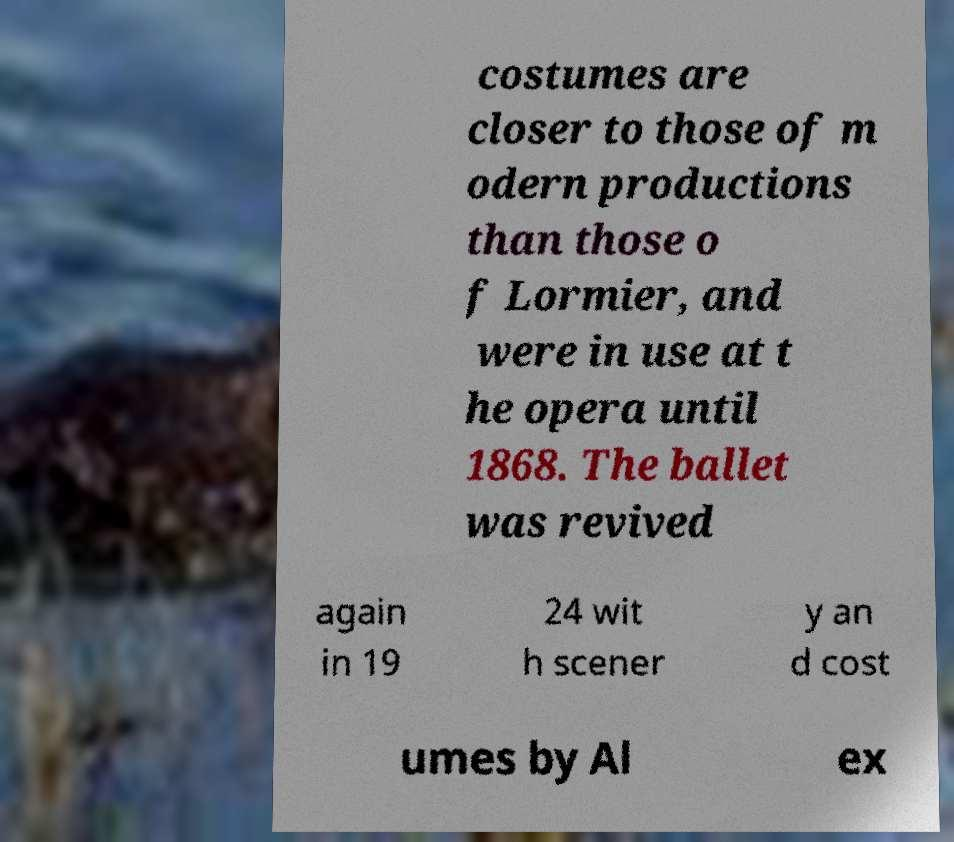I need the written content from this picture converted into text. Can you do that? costumes are closer to those of m odern productions than those o f Lormier, and were in use at t he opera until 1868. The ballet was revived again in 19 24 wit h scener y an d cost umes by Al ex 